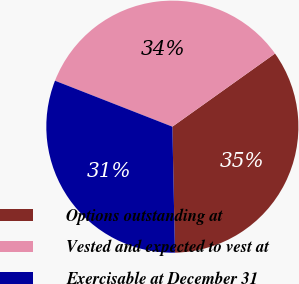<chart> <loc_0><loc_0><loc_500><loc_500><pie_chart><fcel>Options outstanding at<fcel>Vested and expected to vest at<fcel>Exercisable at December 31<nl><fcel>34.52%<fcel>34.21%<fcel>31.27%<nl></chart> 